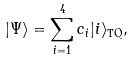Convert formula to latex. <formula><loc_0><loc_0><loc_500><loc_500>| \Psi \rangle = \sum _ { i = 1 } ^ { 4 } c _ { i } | i \rangle _ { \text {TQ} } ,</formula> 